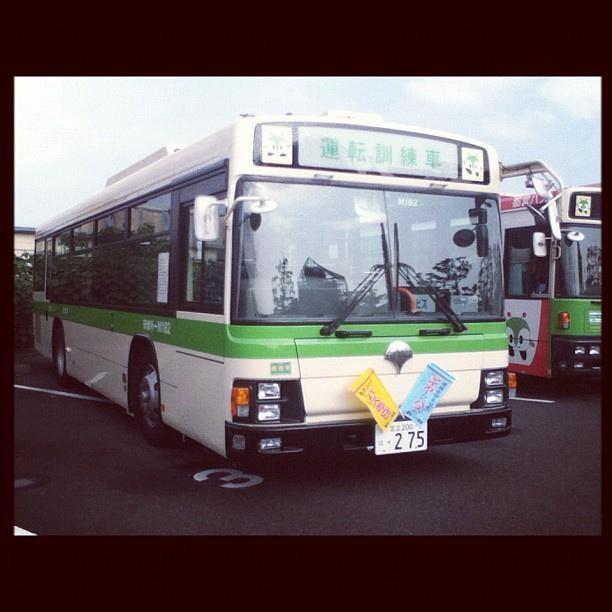How many buses are in the picture?
Give a very brief answer. 2. How many blue bicycles are there?
Give a very brief answer. 0. 